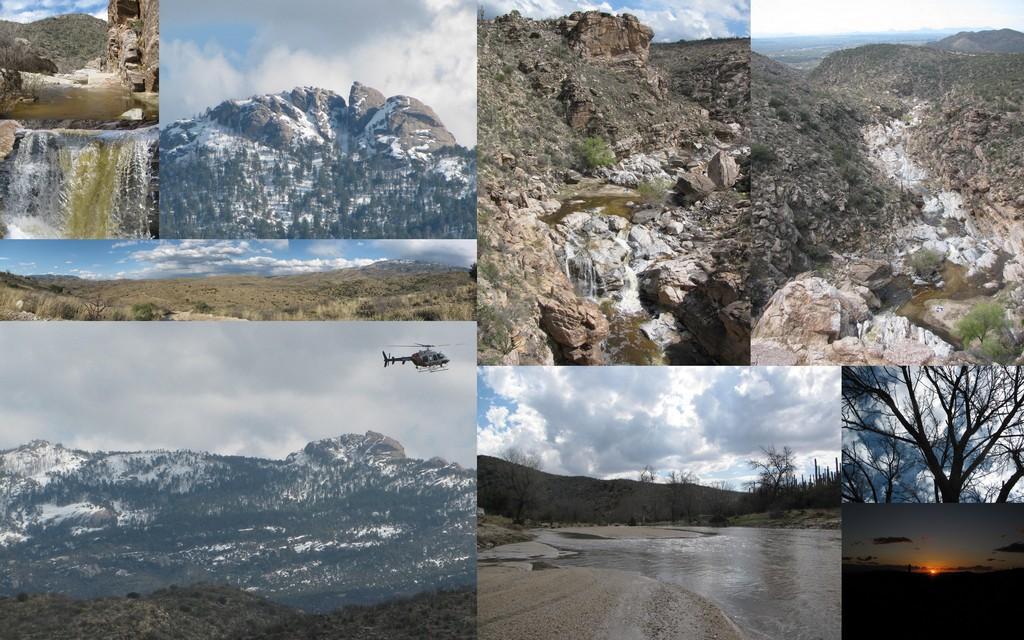Can you describe this image briefly? This is an edited image and the picture has been collaged in which there are mountains, trees and there is an helicopter flying in the sky and there is water and the sky is cloudy. 